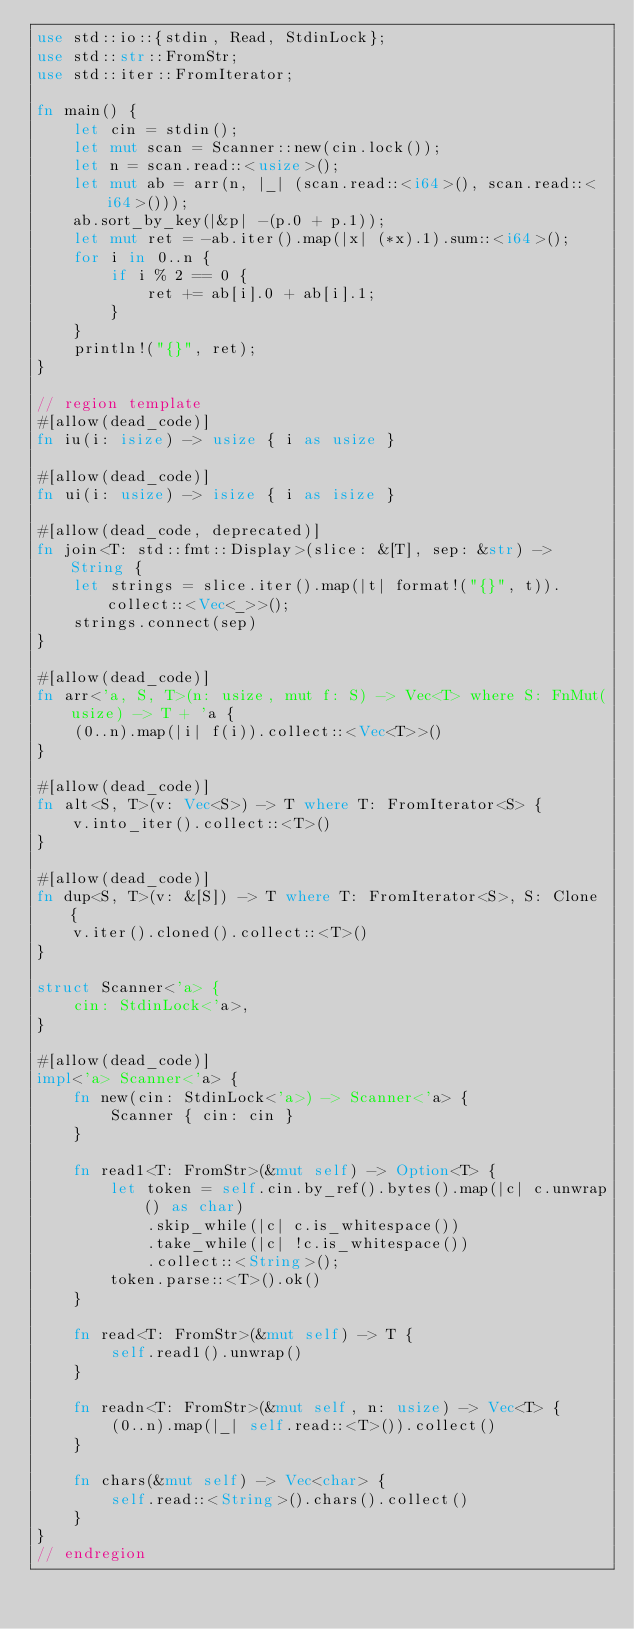<code> <loc_0><loc_0><loc_500><loc_500><_Rust_>use std::io::{stdin, Read, StdinLock};
use std::str::FromStr;
use std::iter::FromIterator;

fn main() {
    let cin = stdin();
    let mut scan = Scanner::new(cin.lock());
    let n = scan.read::<usize>();
    let mut ab = arr(n, |_| (scan.read::<i64>(), scan.read::<i64>()));
    ab.sort_by_key(|&p| -(p.0 + p.1));
    let mut ret = -ab.iter().map(|x| (*x).1).sum::<i64>();
    for i in 0..n {
        if i % 2 == 0 {
            ret += ab[i].0 + ab[i].1;
        }
    }
    println!("{}", ret);
}

// region template
#[allow(dead_code)]
fn iu(i: isize) -> usize { i as usize }

#[allow(dead_code)]
fn ui(i: usize) -> isize { i as isize }

#[allow(dead_code, deprecated)]
fn join<T: std::fmt::Display>(slice: &[T], sep: &str) -> String {
    let strings = slice.iter().map(|t| format!("{}", t)).collect::<Vec<_>>();
    strings.connect(sep)
}

#[allow(dead_code)]
fn arr<'a, S, T>(n: usize, mut f: S) -> Vec<T> where S: FnMut(usize) -> T + 'a {
    (0..n).map(|i| f(i)).collect::<Vec<T>>()
}

#[allow(dead_code)]
fn alt<S, T>(v: Vec<S>) -> T where T: FromIterator<S> {
    v.into_iter().collect::<T>()
}

#[allow(dead_code)]
fn dup<S, T>(v: &[S]) -> T where T: FromIterator<S>, S: Clone {
    v.iter().cloned().collect::<T>()
}

struct Scanner<'a> {
    cin: StdinLock<'a>,
}

#[allow(dead_code)]
impl<'a> Scanner<'a> {
    fn new(cin: StdinLock<'a>) -> Scanner<'a> {
        Scanner { cin: cin }
    }

    fn read1<T: FromStr>(&mut self) -> Option<T> {
        let token = self.cin.by_ref().bytes().map(|c| c.unwrap() as char)
            .skip_while(|c| c.is_whitespace())
            .take_while(|c| !c.is_whitespace())
            .collect::<String>();
        token.parse::<T>().ok()
    }

    fn read<T: FromStr>(&mut self) -> T {
        self.read1().unwrap()
    }

    fn readn<T: FromStr>(&mut self, n: usize) -> Vec<T> {
        (0..n).map(|_| self.read::<T>()).collect()
    }

    fn chars(&mut self) -> Vec<char> {
        self.read::<String>().chars().collect()
    }
}
// endregion</code> 